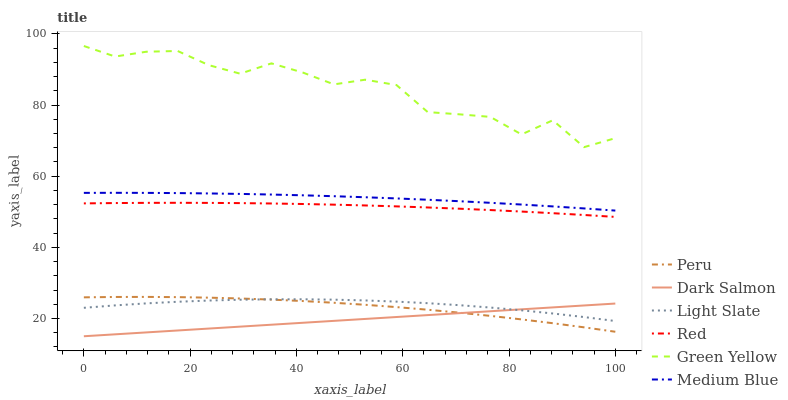Does Dark Salmon have the minimum area under the curve?
Answer yes or no. Yes. Does Green Yellow have the maximum area under the curve?
Answer yes or no. Yes. Does Medium Blue have the minimum area under the curve?
Answer yes or no. No. Does Medium Blue have the maximum area under the curve?
Answer yes or no. No. Is Dark Salmon the smoothest?
Answer yes or no. Yes. Is Green Yellow the roughest?
Answer yes or no. Yes. Is Medium Blue the smoothest?
Answer yes or no. No. Is Medium Blue the roughest?
Answer yes or no. No. Does Medium Blue have the lowest value?
Answer yes or no. No. Does Green Yellow have the highest value?
Answer yes or no. Yes. Does Medium Blue have the highest value?
Answer yes or no. No. Is Peru less than Green Yellow?
Answer yes or no. Yes. Is Red greater than Dark Salmon?
Answer yes or no. Yes. Does Peru intersect Dark Salmon?
Answer yes or no. Yes. Is Peru less than Dark Salmon?
Answer yes or no. No. Is Peru greater than Dark Salmon?
Answer yes or no. No. Does Peru intersect Green Yellow?
Answer yes or no. No. 